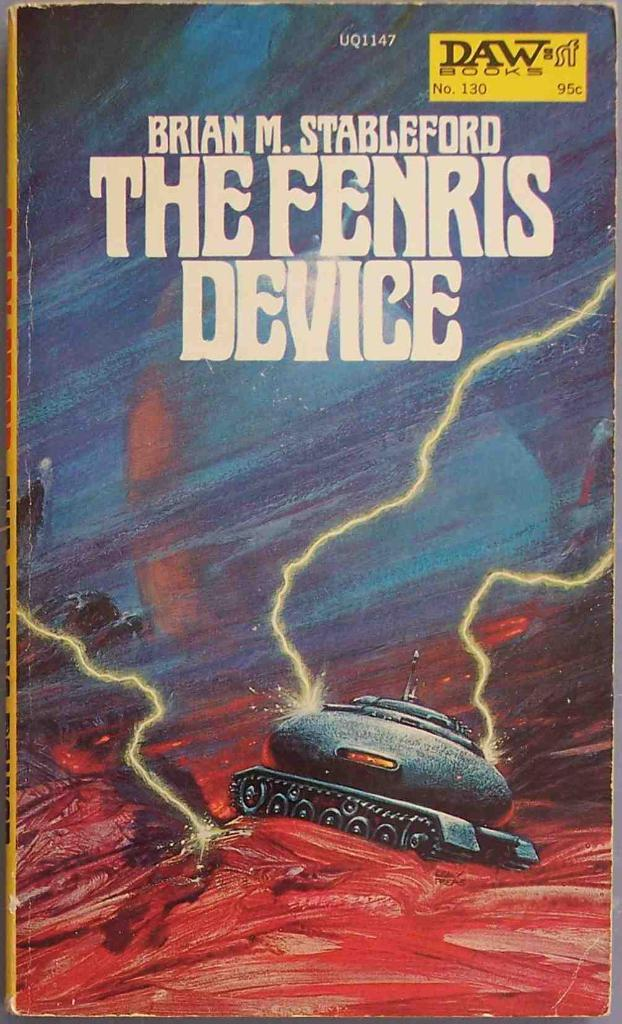<image>
Summarize the visual content of the image. a copy of the book The fenris device written by brian m. stableford. 